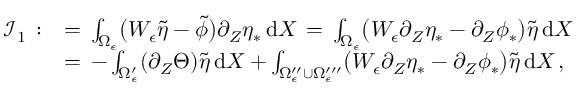Convert formula to latex. <formula><loc_0><loc_0><loc_500><loc_500>\begin{array} { r l } { \mathcal { I } _ { 1 } \, \colon } & { = \, \int _ { \Omega _ { \epsilon } } \left ( W _ { \epsilon } \tilde { \eta } - \tilde { \phi } \right ) \partial _ { Z } \eta _ { * } \, d X \, = \, \int _ { \Omega _ { \epsilon } } \left ( W _ { \epsilon } \partial _ { Z } \eta _ { * } - \partial _ { Z } \phi _ { * } \right ) \tilde { \eta } \, d X } \\ { \, } & { = \, - \int _ { \Omega _ { \epsilon } ^ { \prime } } ( \partial _ { Z } \Theta ) \tilde { \eta } \, d X + \int _ { \Omega _ { \epsilon } ^ { \prime \prime } \cup \Omega _ { \epsilon } ^ { \prime \prime \prime } } \left ( W _ { \epsilon } \partial _ { Z } \eta _ { * } - \partial _ { Z } \phi _ { * } \right ) \tilde { \eta } \, d X \, , } \end{array}</formula> 